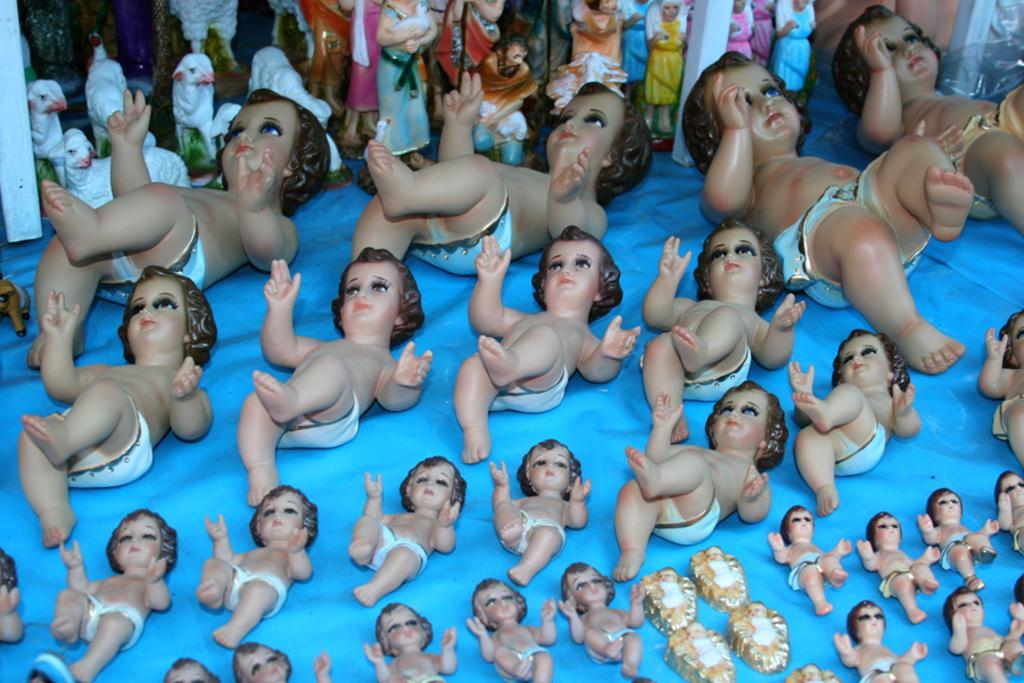What type of objects are present in the image? There are many toys in the image. Can you describe the appearance of the toys? The toys come in different colors and sizes. What is the toys placed on in the image? The toys are placed on a blue cloth. Can you tell me how many bananas are in the image? There are no bananas present in the image; it features toys placed on a blue cloth. What type of servant is shown attending to the toys in the image? There is no servant present in the image; it only features toys placed on a blue cloth. 